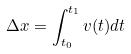<formula> <loc_0><loc_0><loc_500><loc_500>\Delta x = \int _ { t _ { 0 } } ^ { t _ { 1 } } v ( t ) d t</formula> 